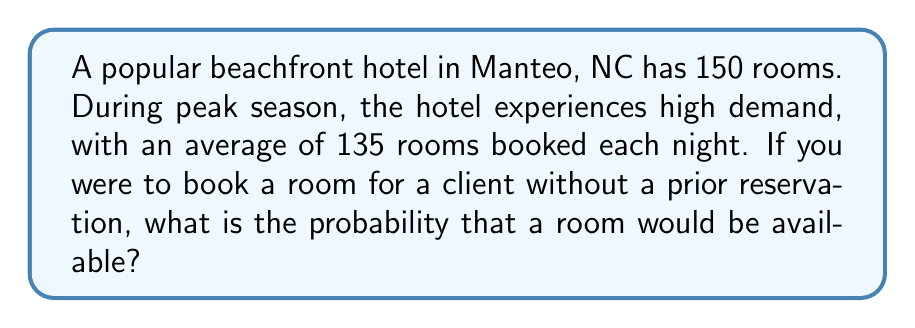Could you help me with this problem? Let's approach this step-by-step:

1) First, we need to determine the probability of a room being occupied. This can be calculated by dividing the average number of booked rooms by the total number of rooms:

   $P(\text{room occupied}) = \frac{\text{average booked rooms}}{\text{total rooms}} = \frac{135}{150} = 0.9$

2) The probability of a room being available is the complement of the probability of a room being occupied:

   $P(\text{room available}) = 1 - P(\text{room occupied})$

3) Substituting the value we calculated in step 1:

   $P(\text{room available}) = 1 - 0.9 = 0.1$

4) To express this as a percentage:

   $0.1 \times 100\% = 10\%$

Therefore, the probability of finding an available room during peak season is 10% or 0.1.
Answer: 0.1 or 10% 